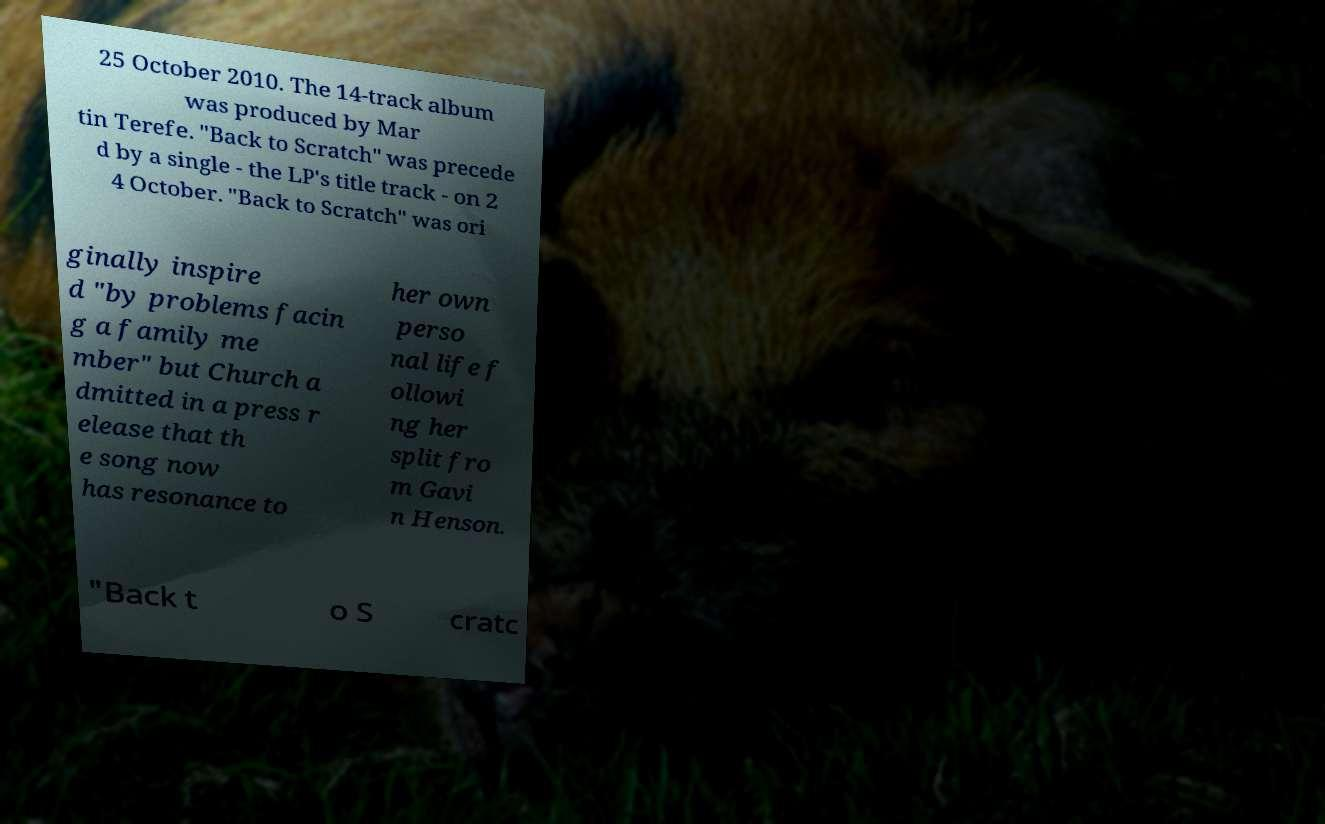Could you extract and type out the text from this image? 25 October 2010. The 14-track album was produced by Mar tin Terefe. "Back to Scratch" was precede d by a single - the LP's title track - on 2 4 October. "Back to Scratch" was ori ginally inspire d "by problems facin g a family me mber" but Church a dmitted in a press r elease that th e song now has resonance to her own perso nal life f ollowi ng her split fro m Gavi n Henson. "Back t o S cratc 